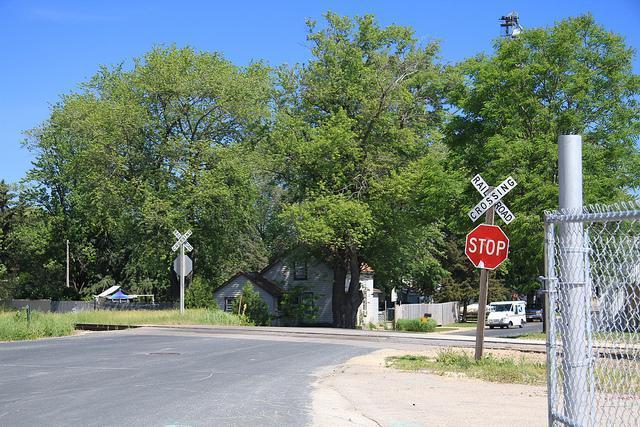How many trains are on the track?
Give a very brief answer. 0. How many stop signs is there?
Give a very brief answer. 2. How many giraffes are there?
Give a very brief answer. 0. 